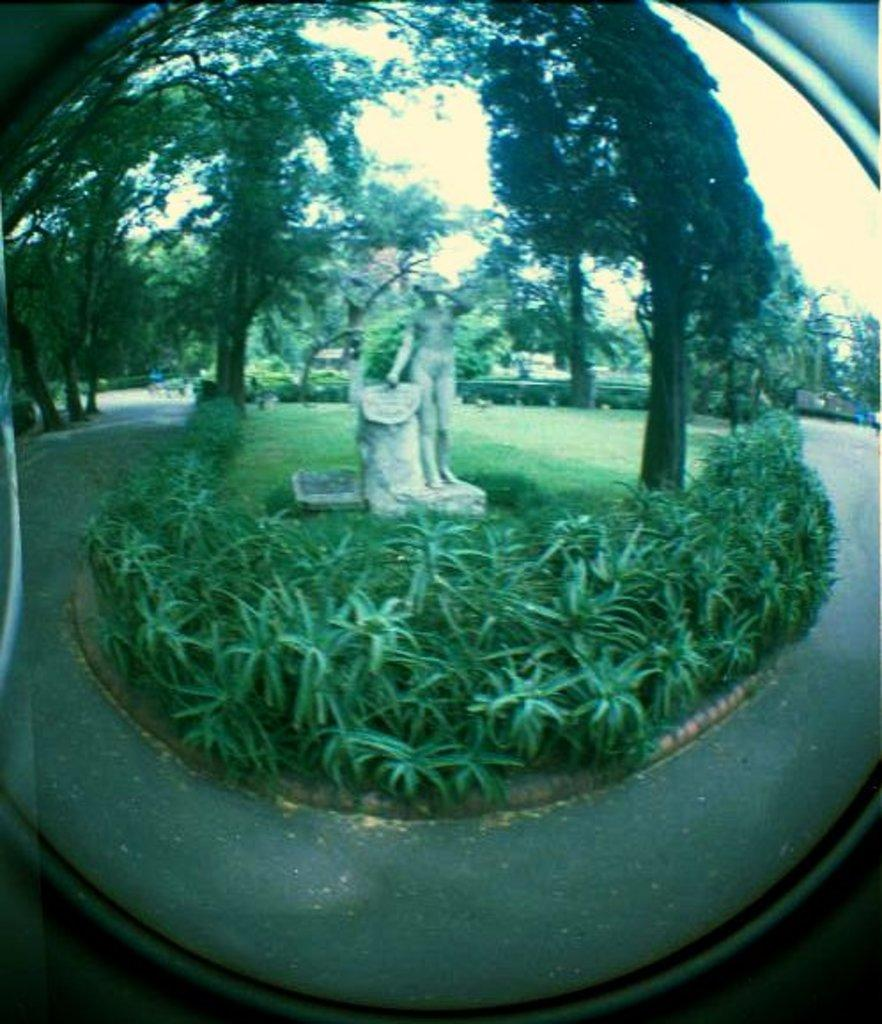What object in the image reflects an image? There is a mirror in the image that reflects a statue of a woman and plants. What is the statue of in the image? The statue is of a woman. What else can be seen in the mirror's reflection? The mirror also reflects plants. What can be seen in the background of the image? There is a road visible in the image. What type of vegetation is present in the garden? There are trees in the garden. Where is the kettle placed in the image? There is no kettle present in the image. What type of nut is being cracked by the baby in the image? There is no baby or nut present in the image. 